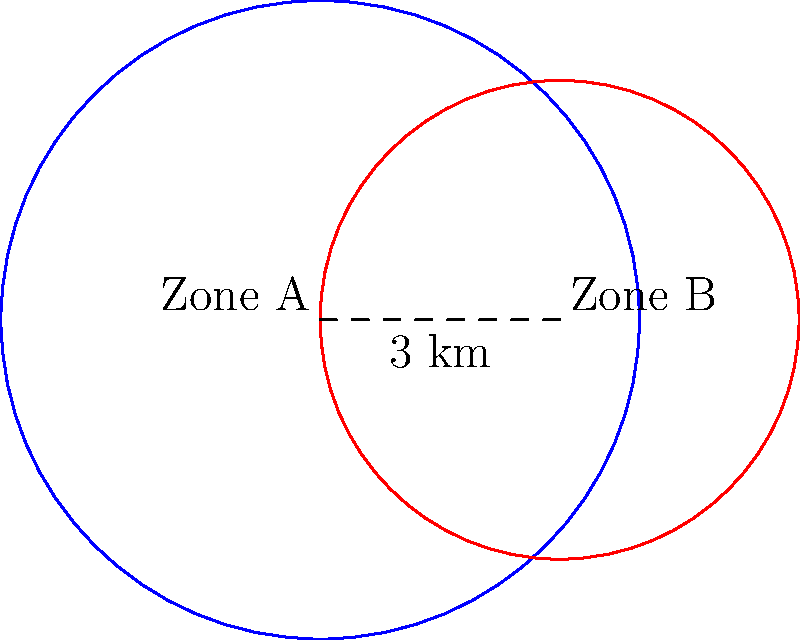Two circular zoning areas, Zone A and Zone B, have radii of 4 km and 3 km respectively, with their centers located 3 km apart. As a regulatory compliance officer, you need to estimate the overlapping area to assess potential conflicts in zoning regulations. What is the approximate area of overlap between these two zones? (Use $\pi \approx 3.14$ for calculations) To estimate the area of overlap between two circles, we can use the following steps:

1) First, we need to calculate the distance $d$ between the points of intersection of the two circles. We can use the formula:

   $d = 2\sqrt{\frac{(r_1+r_2-a)(r_1-r_2+a)(-r_1+r_2+a)(r_1+r_2+a)}{4a^2}}$

   Where $r_1 = 4$ km, $r_2 = 3$ km, and $a = 3$ km (distance between centers)

2) Plugging in the values:
   
   $d = 2\sqrt{\frac{(4+3-3)(4-3+3)(-4+3+3)(4+3+3)}{4(3^2)}}$
   $= 2\sqrt{\frac{4 \cdot 4 \cdot 2 \cdot 10}{36}} = 2\sqrt{\frac{320}{36}} \approx 5.96$ km

3) Now we can calculate the areas of the two circular segments. The formula for the area of a circular segment is:

   $A = r^2 \arccos(\frac{r-h}{r}) - (r-h)\sqrt{2rh-h^2}$

   Where $h = r - \frac{a}{2} = r - 1.5$ for both circles

4) For Zone A: $h_1 = 4 - 1.5 = 2.5$
   $A_1 = 4^2 \arccos(\frac{4-2.5}{4}) - (4-2.5)\sqrt{2(4)(2.5)-(2.5)^2}$
   $\approx 16(1.0472) - 1.5(4.3301) \approx 10.3752$ km²

5) For Zone B: $h_2 = 3 - 1.5 = 1.5$
   $A_2 = 3^2 \arccos(\frac{3-1.5}{3}) - (3-1.5)\sqrt{2(3)(1.5)-(1.5)^2}$
   $\approx 9(1.2490) - 1.5(3) \approx 6.7410$ km²

6) The total overlapping area is the sum of these two segments:
   $A_{total} = A_1 + A_2 \approx 10.3752 + 6.7410 = 17.1162$ km²

Therefore, the approximate area of overlap is 17.12 km².
Answer: 17.12 km² 